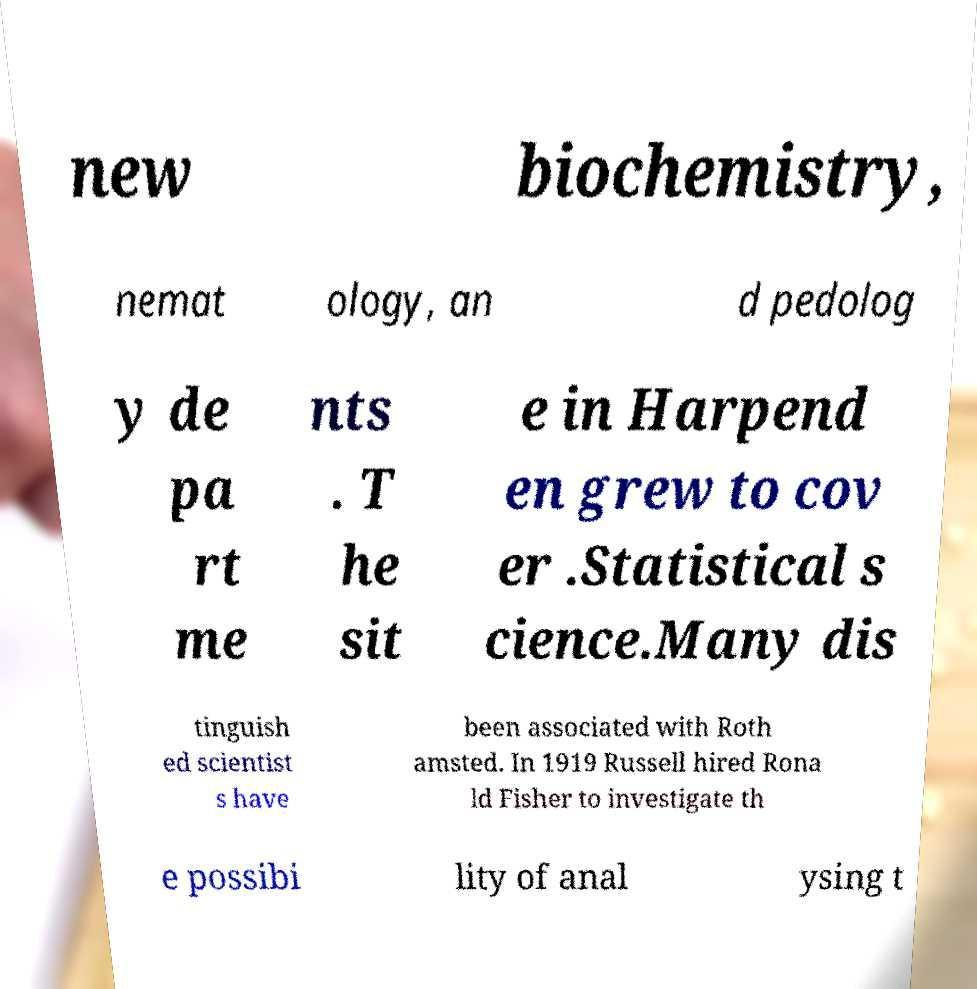Can you accurately transcribe the text from the provided image for me? new biochemistry, nemat ology, an d pedolog y de pa rt me nts . T he sit e in Harpend en grew to cov er .Statistical s cience.Many dis tinguish ed scientist s have been associated with Roth amsted. In 1919 Russell hired Rona ld Fisher to investigate th e possibi lity of anal ysing t 